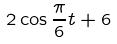<formula> <loc_0><loc_0><loc_500><loc_500>2 \cos \frac { \pi } { 6 } t + 6</formula> 